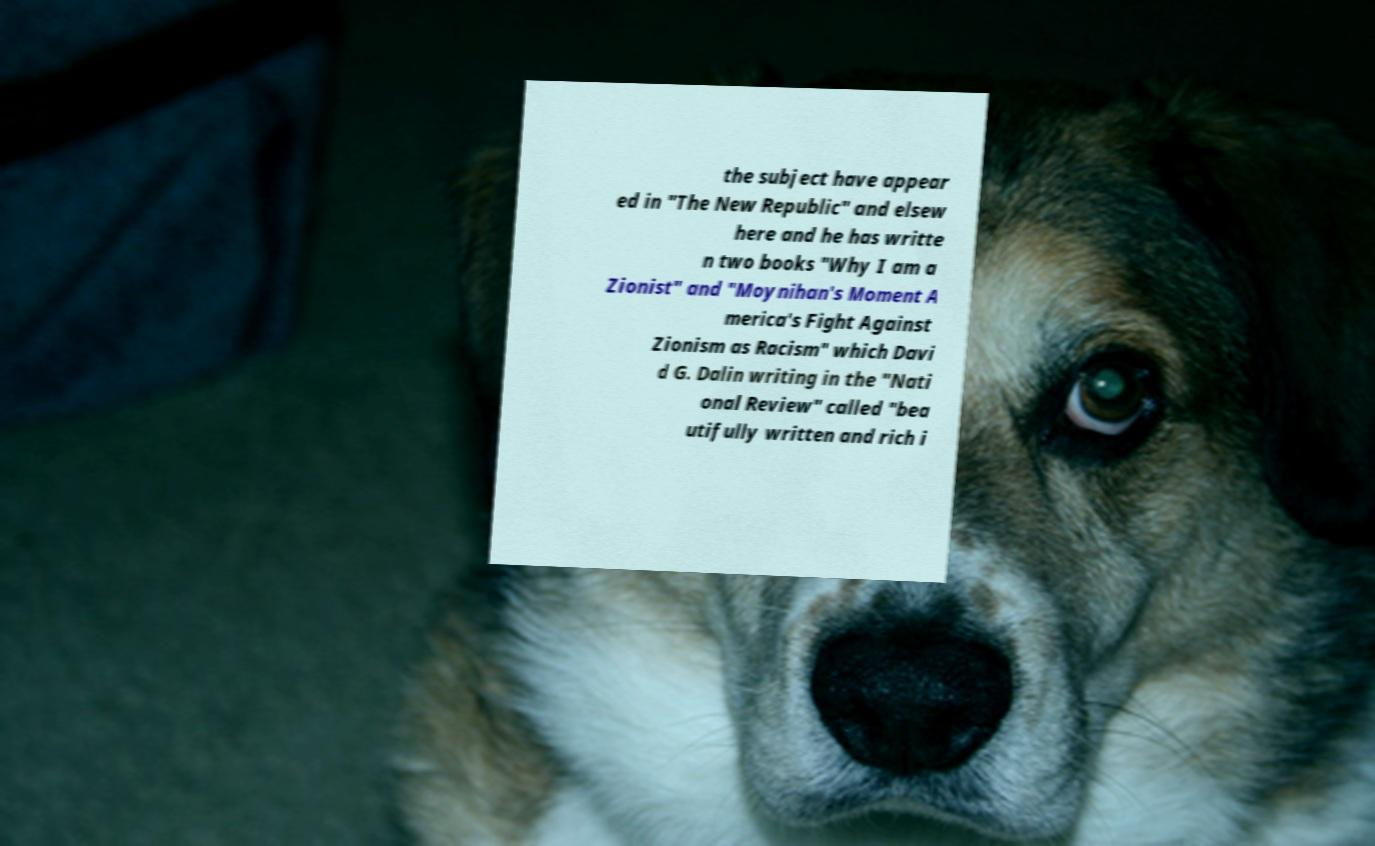Could you assist in decoding the text presented in this image and type it out clearly? the subject have appear ed in "The New Republic" and elsew here and he has writte n two books "Why I am a Zionist" and "Moynihan's Moment A merica's Fight Against Zionism as Racism" which Davi d G. Dalin writing in the "Nati onal Review" called "bea utifully written and rich i 